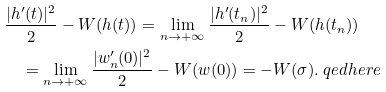Convert formula to latex. <formula><loc_0><loc_0><loc_500><loc_500>& \frac { | h ^ { \prime } ( t ) | ^ { 2 } } { 2 } - W ( h ( t ) ) = \lim _ { n \rightarrow + \infty } \frac { | h ^ { \prime } ( t _ { n } ) | ^ { 2 } } { 2 } - W ( h ( t _ { n } ) ) \\ & \quad = \lim _ { n \rightarrow + \infty } \frac { | w ^ { \prime } _ { n } ( 0 ) | ^ { 2 } } { 2 } - W ( w ( 0 ) ) = - W ( \sigma ) . \ q e d h e r e</formula> 